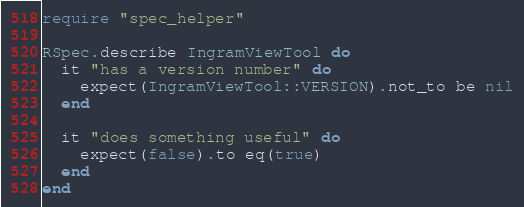<code> <loc_0><loc_0><loc_500><loc_500><_Ruby_>require "spec_helper"

RSpec.describe IngramViewTool do
  it "has a version number" do
    expect(IngramViewTool::VERSION).not_to be nil
  end

  it "does something useful" do
    expect(false).to eq(true)
  end
end
</code> 